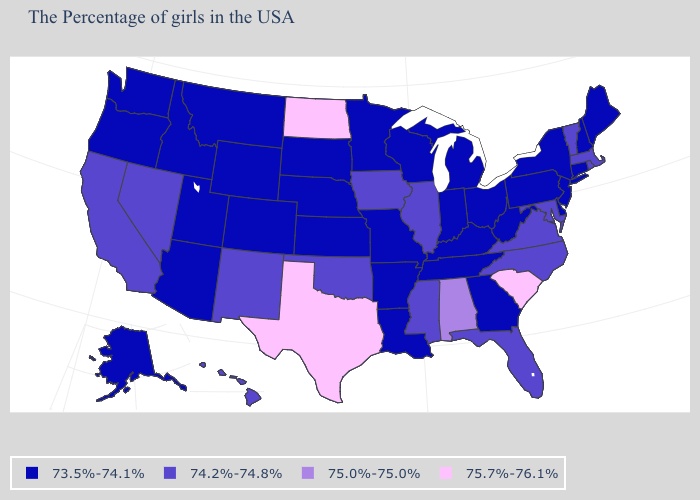Among the states that border Nevada , which have the highest value?
Concise answer only. California. What is the value of Kentucky?
Answer briefly. 73.5%-74.1%. Name the states that have a value in the range 74.2%-74.8%?
Write a very short answer. Massachusetts, Rhode Island, Vermont, Maryland, Virginia, North Carolina, Florida, Illinois, Mississippi, Iowa, Oklahoma, New Mexico, Nevada, California, Hawaii. Is the legend a continuous bar?
Give a very brief answer. No. Is the legend a continuous bar?
Short answer required. No. Which states have the lowest value in the MidWest?
Quick response, please. Ohio, Michigan, Indiana, Wisconsin, Missouri, Minnesota, Kansas, Nebraska, South Dakota. Name the states that have a value in the range 75.7%-76.1%?
Short answer required. South Carolina, Texas, North Dakota. What is the value of North Dakota?
Keep it brief. 75.7%-76.1%. Does South Carolina have the highest value in the USA?
Short answer required. Yes. What is the value of Massachusetts?
Be succinct. 74.2%-74.8%. Among the states that border West Virginia , which have the lowest value?
Short answer required. Pennsylvania, Ohio, Kentucky. Which states have the lowest value in the Northeast?
Write a very short answer. Maine, New Hampshire, Connecticut, New York, New Jersey, Pennsylvania. What is the lowest value in the USA?
Answer briefly. 73.5%-74.1%. Name the states that have a value in the range 75.0%-75.0%?
Keep it brief. Alabama. Which states hav the highest value in the South?
Quick response, please. South Carolina, Texas. 